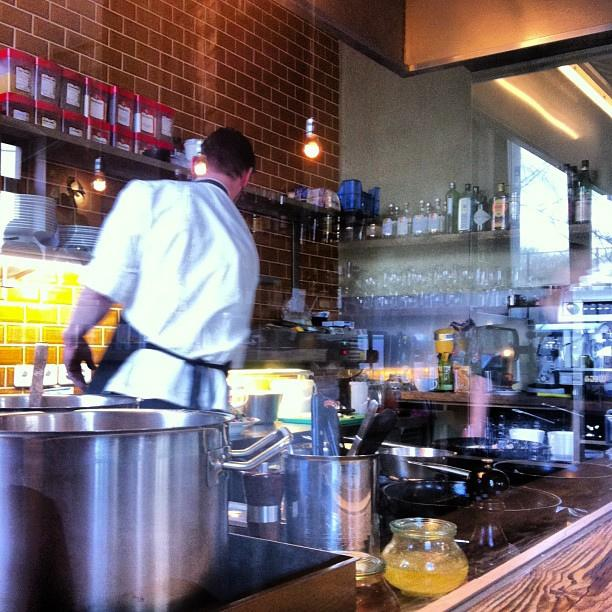What is on the counter? Please explain your reasoning. pot. This is a commercial kitchen and that is a metal vessel used for cooking 